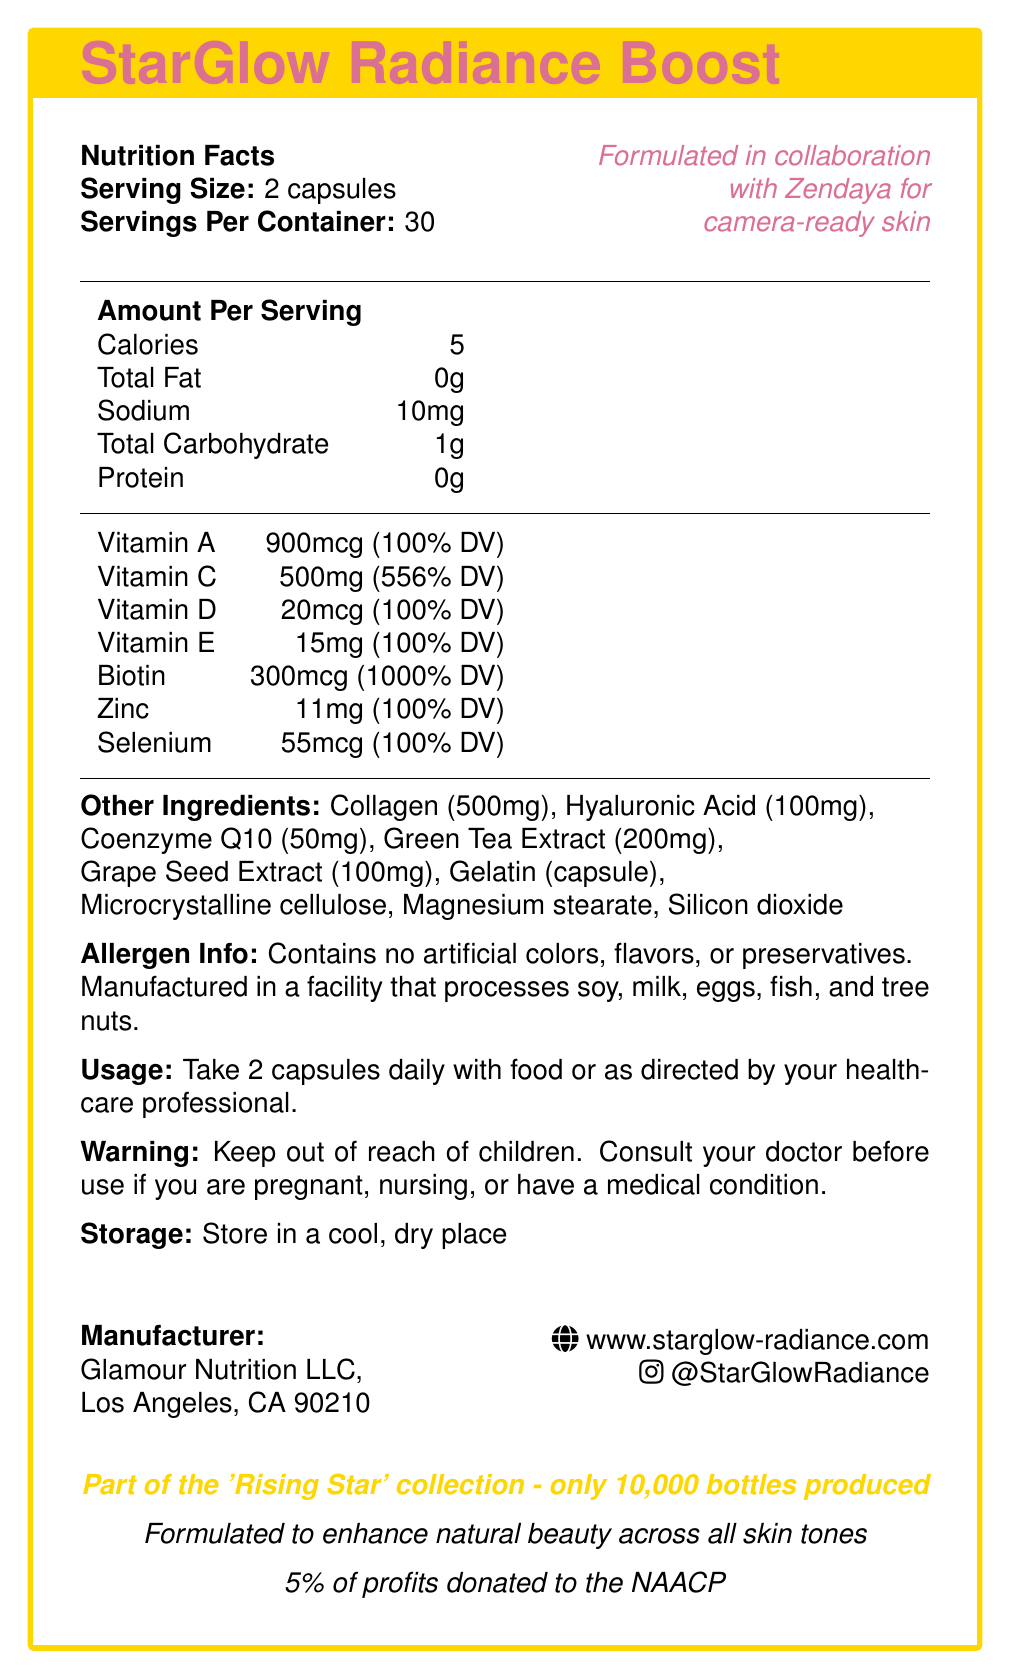What is the name of the product? The name of the product is plainly stated at the beginning of the document as “StarGlow Radiance Boost”.
Answer: StarGlow Radiance Boost How many calories are in a serving? The document lists the calorie content as “Calories: 5” under the nutrition facts.
Answer: 5 calories What is the daily value percentage of Vitamin C provided in each serving? The document lists “Vitamin C” followed by “500mg (556% DV)” showing the daily value percentage.
Answer: 556% Who collaborated in the formulation of this product? The document mentions “Formulated in collaboration with Zendaya” in the top-right section.
Answer: Zendaya How many capsules should be taken daily? The usage instructions state to “Take 2 capsules daily”.
Answer: 2 capsules How much Biotin is in each serving? A. 900mcg B. 500mg C. 300mcg D. 20mcg The document lists “Biotin: 300mcg (1000% DV)” under the amounts per serving.
Answer: C. 300mcg Which of the following ingredients is NOT listed in the document? A. Gelatin B. Ascorbic Acid C. Green Tea Extract D. Collagen Gelatin, Green Tea Extract, and Collagen are listed under “Other Ingredients”, but Ascorbic Acid is not mentioned.
Answer: B. Ascorbic Acid Is the product free from artificial colors, flavors, or preservatives? The allergen info states “Contains no artificial colors, flavors, or preservatives.”
Answer: Yes Please summarize the key details of this document. The summary includes the main points from the document such as product name, collaboration, nutritional information, ingredients, usage, allergen, storage, manufacturer info, and special notes on limited edition and charitable contributions.
Answer: The document is a nutrition facts label for StarGlow Radiance Boost, a limited-edition vitamin supplement endorsed by Zendaya for camera-ready skin. It outlines nutritional facts, major ingredients, usage instructions, allergen information, storage guidelines, and manufacturer details. Additionally, it highlights its charitable contribution and focus on enhancing natural beauty across all skin tones. Is the product suitable for someone with a nut allergy? The product is manufactured in a facility that processes tree nuts, which may not be suitable for someone with a nut allergy, but the document does not guarantee its absolute safety for those with such allergies.
Answer: Not enough information How many servings are there per container? The document states “Servings Per Container: 30” in the nutrition facts section.
Answer: 30 What is the sodium content per serving? Listed as “Sodium: 10mg” under the nutrition facts.
Answer: 10mg What charitable cause does this product contribute to? The document states “5% of profits donated to the NAACP” near the bottom.
Answer: NAACP Which key ingredient is present at 100mg per serving? The document lists Hyaluronic Acid as 100mg under "Other Ingredients".
Answer: Hyaluronic Acid What are the storage instructions for the product? The document explicitly states “Store in a cool, dry place” under the storage section.
Answer: Store in a cool, dry place 